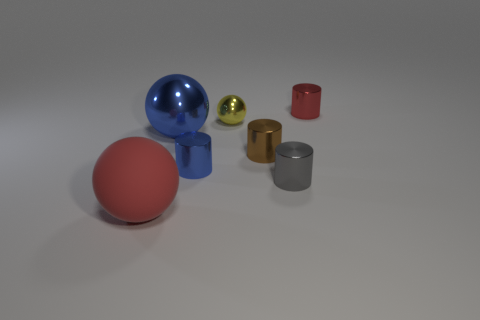How many metallic objects have the same color as the big metallic ball?
Your answer should be very brief. 1. Do the big blue object and the gray object have the same shape?
Keep it short and to the point. No. Is there a yellow metallic object that has the same shape as the big blue shiny thing?
Your answer should be compact. Yes. What is the shape of the red thing that is to the left of the small cylinder that is in front of the tiny blue shiny object?
Your response must be concise. Sphere. What color is the tiny metal object left of the tiny yellow thing?
Offer a very short reply. Blue. The brown thing that is the same material as the tiny blue cylinder is what size?
Offer a very short reply. Small. There is a blue thing that is the same shape as the big red matte object; what is its size?
Provide a short and direct response. Large. Are there any tiny spheres?
Make the answer very short. Yes. What number of things are cylinders right of the yellow metallic object or tiny objects?
Provide a succinct answer. 5. There is another sphere that is the same size as the blue metallic sphere; what is it made of?
Your answer should be very brief. Rubber. 